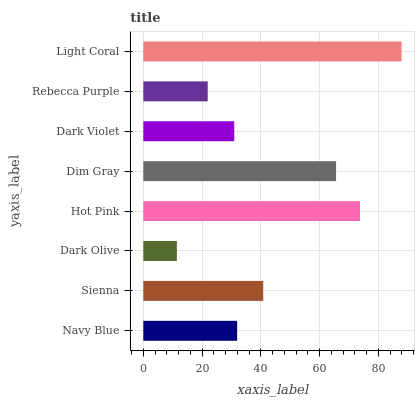Is Dark Olive the minimum?
Answer yes or no. Yes. Is Light Coral the maximum?
Answer yes or no. Yes. Is Sienna the minimum?
Answer yes or no. No. Is Sienna the maximum?
Answer yes or no. No. Is Sienna greater than Navy Blue?
Answer yes or no. Yes. Is Navy Blue less than Sienna?
Answer yes or no. Yes. Is Navy Blue greater than Sienna?
Answer yes or no. No. Is Sienna less than Navy Blue?
Answer yes or no. No. Is Sienna the high median?
Answer yes or no. Yes. Is Navy Blue the low median?
Answer yes or no. Yes. Is Dark Olive the high median?
Answer yes or no. No. Is Dark Olive the low median?
Answer yes or no. No. 